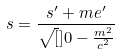<formula> <loc_0><loc_0><loc_500><loc_500>s = \frac { s ^ { \prime } + m e ^ { \prime } } { \sqrt { [ } ] { 0 - \frac { m ^ { 2 } } { c ^ { 2 } } } }</formula> 